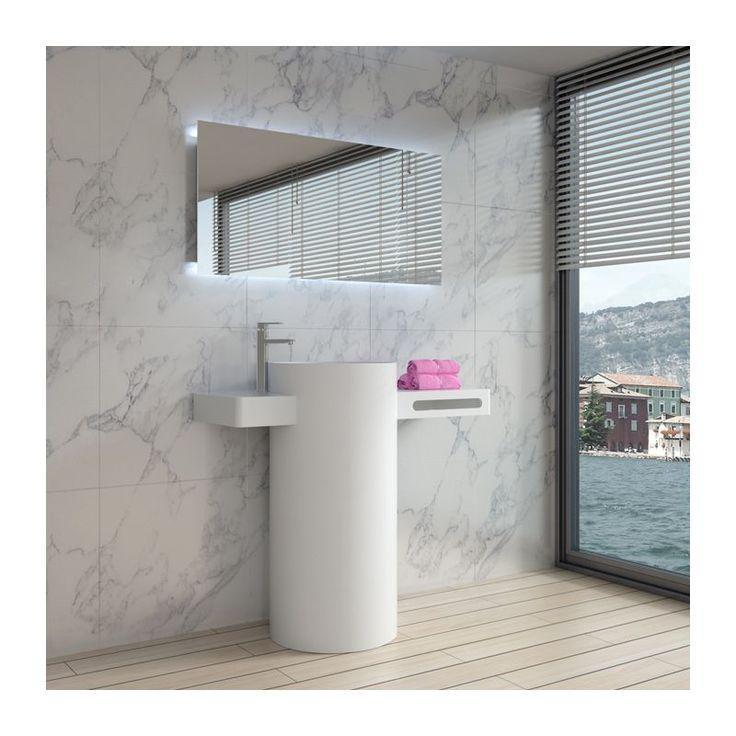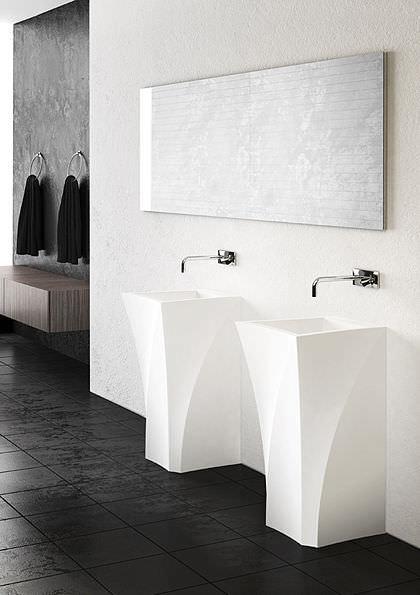The first image is the image on the left, the second image is the image on the right. For the images displayed, is the sentence "In one image, two tall narrow sinks are standing side by side, while a second image shows a single sink with a towel." factually correct? Answer yes or no. Yes. The first image is the image on the left, the second image is the image on the right. For the images displayed, is the sentence "The left image shows one white upright sink that stands on the floor, and the right image contains side-by-side but unconnected upright white sinks." factually correct? Answer yes or no. Yes. 